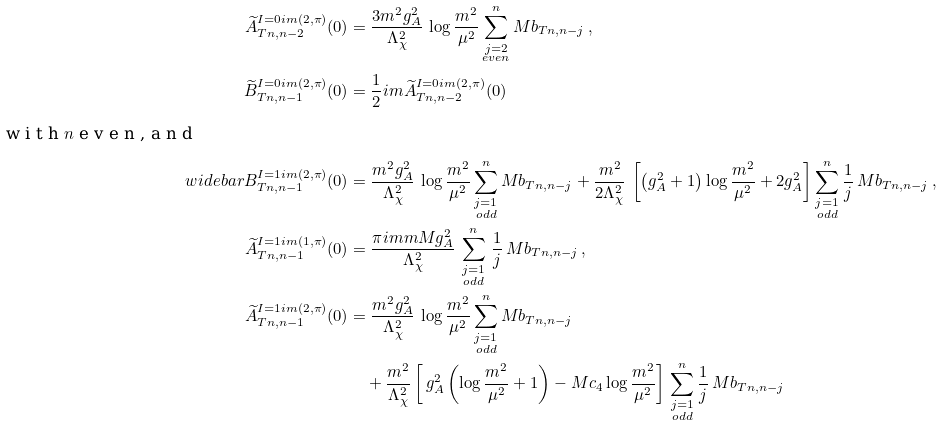Convert formula to latex. <formula><loc_0><loc_0><loc_500><loc_500>\widetilde { A } _ { T n , n - 2 } ^ { I = 0 \sl i m ( 2 , \pi ) } ( 0 ) & = \frac { 3 m ^ { 2 } g _ { A } ^ { 2 } } { \Lambda _ { \chi } ^ { 2 } } \, \log \frac { m ^ { 2 } } { \mu ^ { 2 } } \sum _ { \substack { j = 2 \\ e v e n } } ^ { n } M b _ { T n , n - j } \, , \\ \widetilde { B } _ { T n , n - 1 } ^ { I = 0 \sl i m ( 2 , \pi ) } ( 0 ) & = \frac { 1 } { 2 } \sl i m \widetilde { A } _ { T n , n - 2 } ^ { I = 0 \sl i m ( 2 , \pi ) } ( 0 ) \\ \intertext { w i t h $ n $ e v e n , a n d } \ w i d e b a r { B } _ { T n , n - 1 } ^ { I = 1 \sl i m ( 2 , \pi ) } ( 0 ) & = \frac { m ^ { 2 } g _ { A } ^ { 2 } } { \Lambda _ { \chi } ^ { 2 } } \, \log \frac { m ^ { 2 } } { \mu ^ { 2 } } \sum _ { \substack { j = 1 \\ o d d } } ^ { n } M b _ { T n , n - j } + \frac { m ^ { 2 } } { 2 \Lambda _ { \chi } ^ { 2 } } \, \left [ \left ( g _ { A } ^ { 2 } + 1 \right ) \log \frac { m ^ { 2 } } { \mu ^ { 2 } } + 2 g _ { A } ^ { 2 } \right ] \sum _ { \substack { j = 1 \\ o d d } } ^ { n } \frac { 1 } { j } \, M b _ { T n , n - j } \, , \\ \widetilde { A } _ { T n , n - 1 } ^ { I = 1 \sl i m ( 1 , \pi ) } ( 0 ) & = \frac { \pi \sl i m m M g _ { A } ^ { 2 } } { \Lambda _ { \chi } ^ { 2 } } \, \sum _ { \substack { j = 1 \\ o d d } } ^ { n } \, \frac { 1 } { j } \, M b _ { T n , n - j } \, , \\ \widetilde { A } _ { T n , n - 1 } ^ { I = 1 \sl i m ( 2 , \pi ) } ( 0 ) & = \frac { m ^ { 2 } g _ { A } ^ { 2 } } { \Lambda _ { \chi } ^ { 2 } } \, \log \frac { m ^ { 2 } } { \mu ^ { 2 } } \sum _ { \substack { j = 1 \\ o d d } } ^ { n } M b _ { T n , n - j } \\ & \quad + \frac { m ^ { 2 } } { \Lambda _ { \chi } ^ { 2 } } \left [ \, g _ { A } ^ { 2 } \left ( \log \frac { m ^ { 2 } } { \mu ^ { 2 } } + 1 \right ) - M c _ { 4 } \log \frac { m ^ { 2 } } { \mu ^ { 2 } } \right ] \, \sum _ { \substack { j = 1 \\ o d d } } ^ { n } \frac { 1 } { j } \, M b _ { T n , n - j }</formula> 